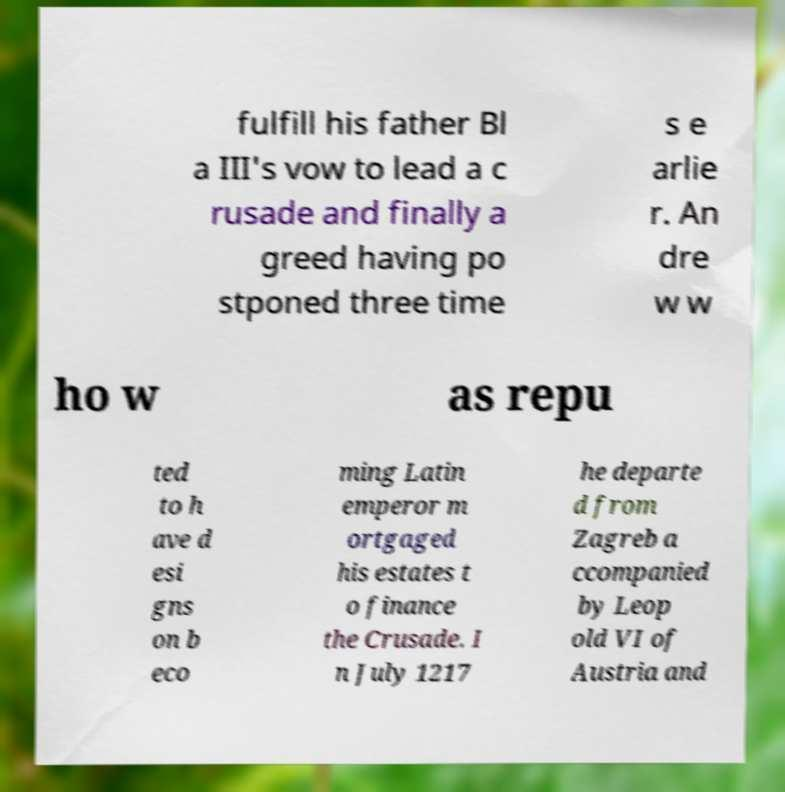I need the written content from this picture converted into text. Can you do that? fulfill his father Bl a III's vow to lead a c rusade and finally a greed having po stponed three time s e arlie r. An dre w w ho w as repu ted to h ave d esi gns on b eco ming Latin emperor m ortgaged his estates t o finance the Crusade. I n July 1217 he departe d from Zagreb a ccompanied by Leop old VI of Austria and 